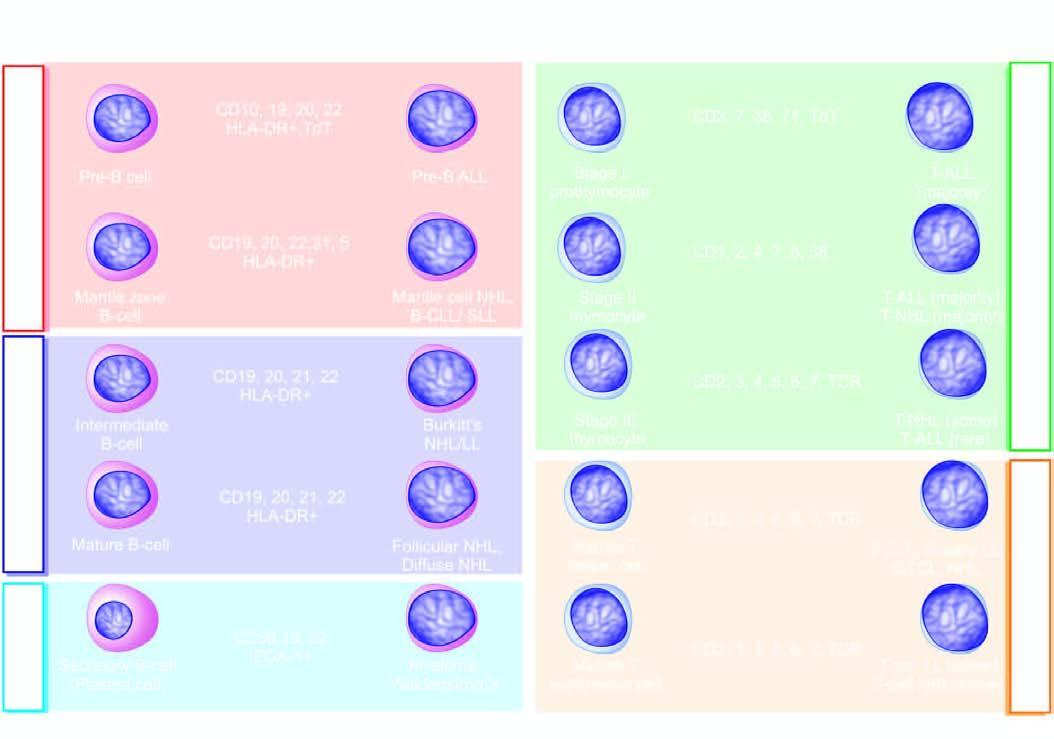what are correlated with normal immunophenotypic differentiation/maturation stages of b and t-cells in the bone marrow, lymphoid tissue, peripheral blood and thymus?
Answer the question using a single word or phrase. Various immunophenotypes of b and t-cell malignancies 